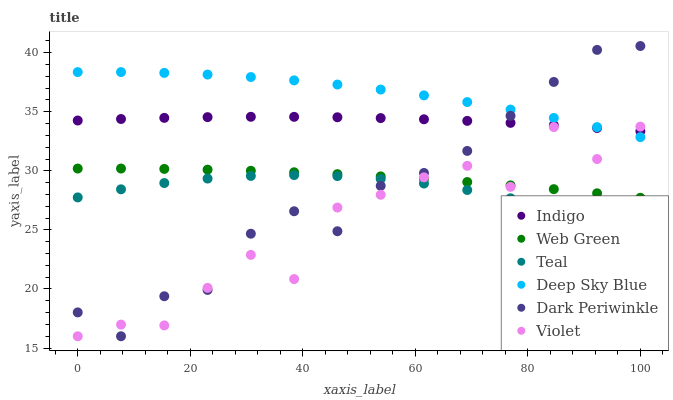Does Violet have the minimum area under the curve?
Answer yes or no. Yes. Does Deep Sky Blue have the maximum area under the curve?
Answer yes or no. Yes. Does Teal have the minimum area under the curve?
Answer yes or no. No. Does Teal have the maximum area under the curve?
Answer yes or no. No. Is Web Green the smoothest?
Answer yes or no. Yes. Is Violet the roughest?
Answer yes or no. Yes. Is Teal the smoothest?
Answer yes or no. No. Is Teal the roughest?
Answer yes or no. No. Does Violet have the lowest value?
Answer yes or no. Yes. Does Teal have the lowest value?
Answer yes or no. No. Does Dark Periwinkle have the highest value?
Answer yes or no. Yes. Does Web Green have the highest value?
Answer yes or no. No. Is Web Green less than Deep Sky Blue?
Answer yes or no. Yes. Is Deep Sky Blue greater than Web Green?
Answer yes or no. Yes. Does Indigo intersect Dark Periwinkle?
Answer yes or no. Yes. Is Indigo less than Dark Periwinkle?
Answer yes or no. No. Is Indigo greater than Dark Periwinkle?
Answer yes or no. No. Does Web Green intersect Deep Sky Blue?
Answer yes or no. No. 